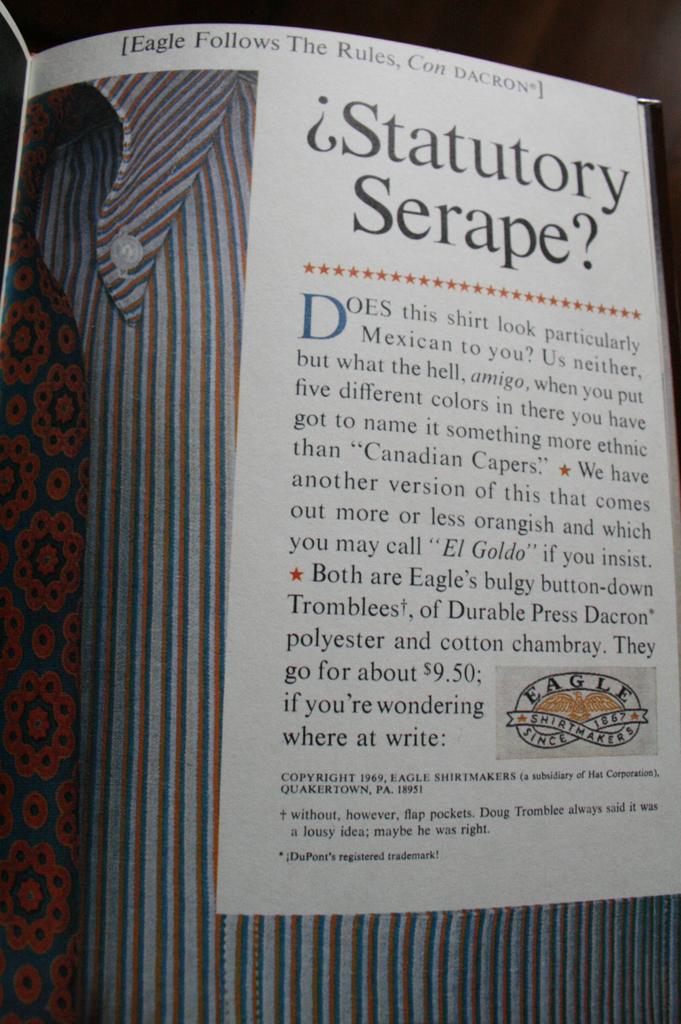What is the word after the read dot?
Make the answer very short. Does. 